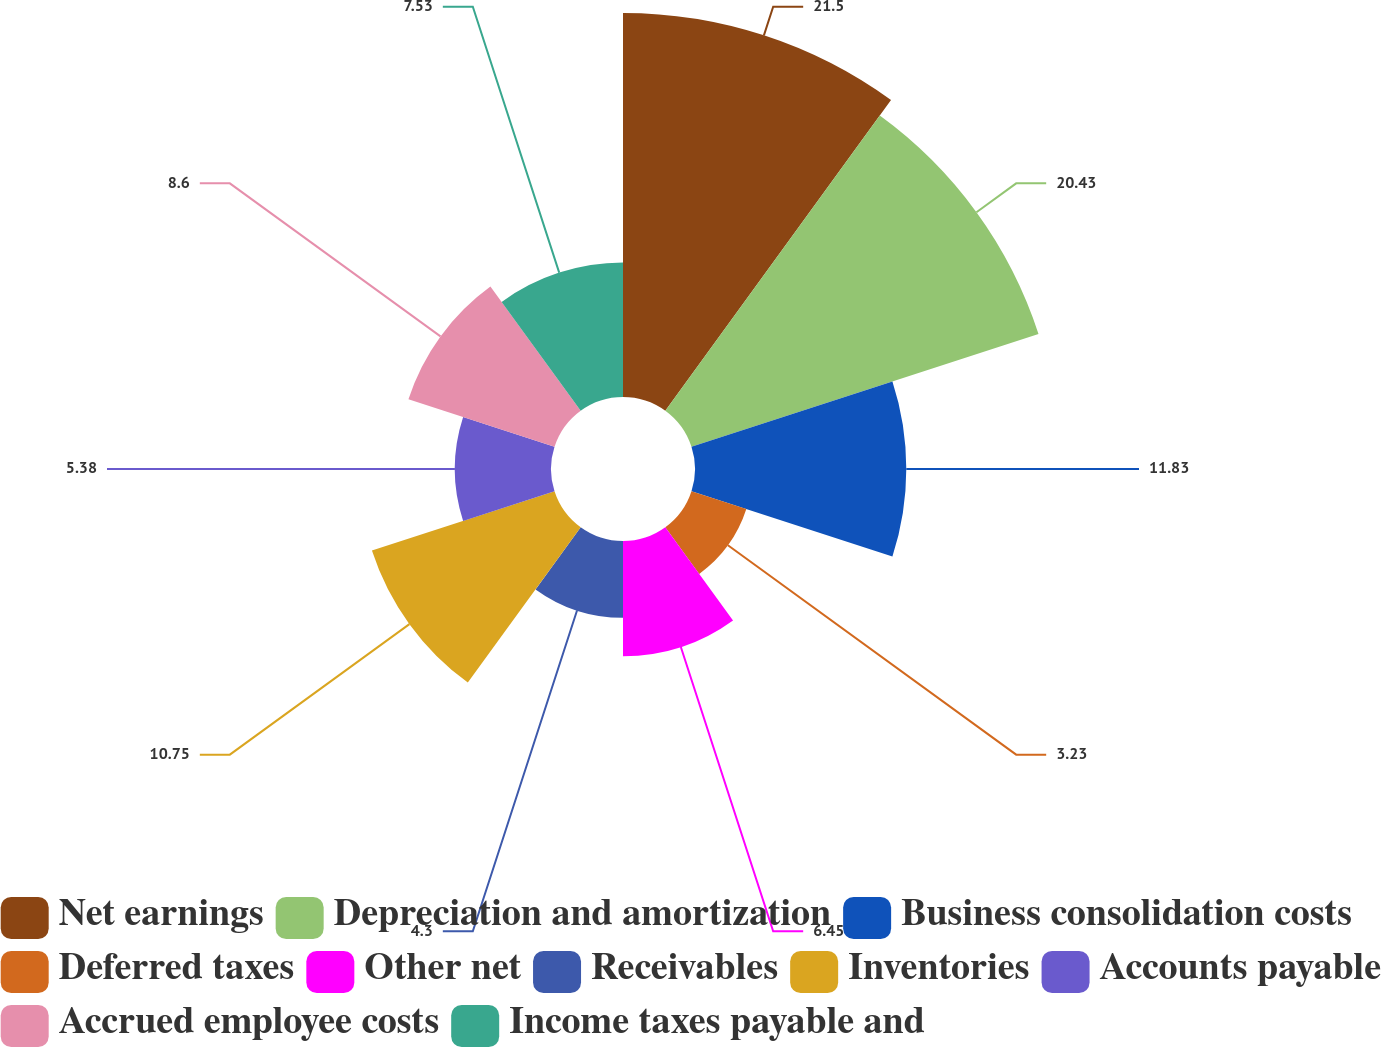Convert chart. <chart><loc_0><loc_0><loc_500><loc_500><pie_chart><fcel>Net earnings<fcel>Depreciation and amortization<fcel>Business consolidation costs<fcel>Deferred taxes<fcel>Other net<fcel>Receivables<fcel>Inventories<fcel>Accounts payable<fcel>Accrued employee costs<fcel>Income taxes payable and<nl><fcel>21.5%<fcel>20.43%<fcel>11.83%<fcel>3.23%<fcel>6.45%<fcel>4.3%<fcel>10.75%<fcel>5.38%<fcel>8.6%<fcel>7.53%<nl></chart> 